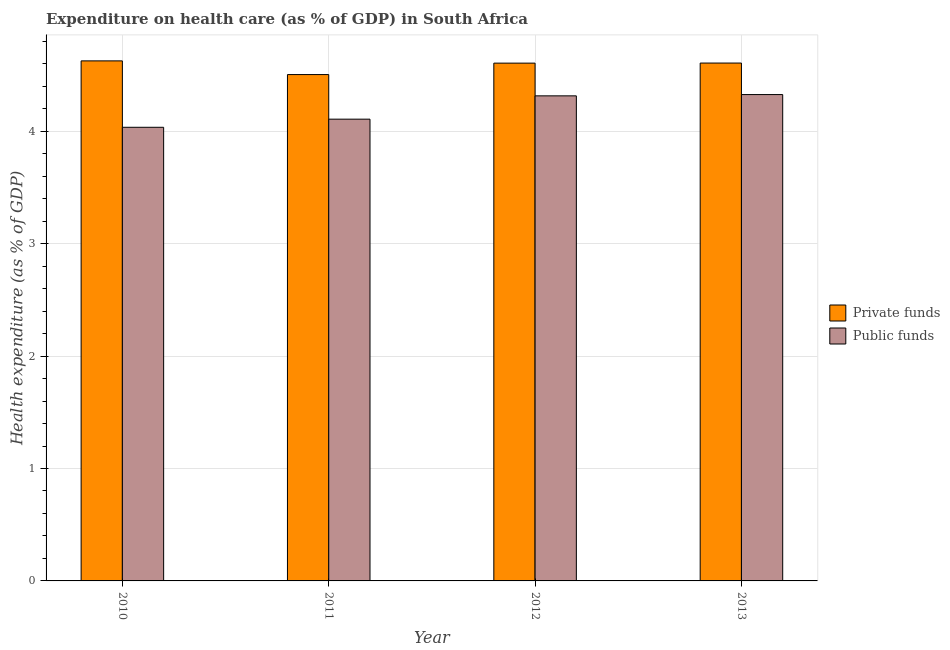How many different coloured bars are there?
Make the answer very short. 2. How many groups of bars are there?
Provide a succinct answer. 4. Are the number of bars per tick equal to the number of legend labels?
Offer a terse response. Yes. How many bars are there on the 4th tick from the left?
Your answer should be very brief. 2. What is the label of the 4th group of bars from the left?
Give a very brief answer. 2013. In how many cases, is the number of bars for a given year not equal to the number of legend labels?
Your answer should be very brief. 0. What is the amount of private funds spent in healthcare in 2011?
Ensure brevity in your answer.  4.5. Across all years, what is the maximum amount of private funds spent in healthcare?
Provide a short and direct response. 4.63. Across all years, what is the minimum amount of private funds spent in healthcare?
Provide a succinct answer. 4.5. In which year was the amount of private funds spent in healthcare maximum?
Offer a terse response. 2010. In which year was the amount of private funds spent in healthcare minimum?
Keep it short and to the point. 2011. What is the total amount of public funds spent in healthcare in the graph?
Your answer should be very brief. 16.78. What is the difference between the amount of private funds spent in healthcare in 2010 and that in 2012?
Your answer should be compact. 0.02. What is the difference between the amount of public funds spent in healthcare in 2013 and the amount of private funds spent in healthcare in 2011?
Your answer should be very brief. 0.22. What is the average amount of public funds spent in healthcare per year?
Your answer should be compact. 4.2. In the year 2011, what is the difference between the amount of private funds spent in healthcare and amount of public funds spent in healthcare?
Offer a very short reply. 0. What is the ratio of the amount of public funds spent in healthcare in 2010 to that in 2012?
Offer a terse response. 0.94. What is the difference between the highest and the second highest amount of public funds spent in healthcare?
Your response must be concise. 0.01. What is the difference between the highest and the lowest amount of private funds spent in healthcare?
Keep it short and to the point. 0.12. What does the 1st bar from the left in 2012 represents?
Your response must be concise. Private funds. What does the 1st bar from the right in 2013 represents?
Provide a succinct answer. Public funds. What is the difference between two consecutive major ticks on the Y-axis?
Offer a very short reply. 1. Are the values on the major ticks of Y-axis written in scientific E-notation?
Offer a terse response. No. Does the graph contain any zero values?
Offer a terse response. No. Does the graph contain grids?
Provide a succinct answer. Yes. Where does the legend appear in the graph?
Offer a very short reply. Center right. How many legend labels are there?
Keep it short and to the point. 2. How are the legend labels stacked?
Provide a succinct answer. Vertical. What is the title of the graph?
Keep it short and to the point. Expenditure on health care (as % of GDP) in South Africa. What is the label or title of the X-axis?
Ensure brevity in your answer.  Year. What is the label or title of the Y-axis?
Your answer should be compact. Health expenditure (as % of GDP). What is the Health expenditure (as % of GDP) in Private funds in 2010?
Provide a succinct answer. 4.63. What is the Health expenditure (as % of GDP) of Public funds in 2010?
Provide a succinct answer. 4.04. What is the Health expenditure (as % of GDP) of Private funds in 2011?
Offer a terse response. 4.5. What is the Health expenditure (as % of GDP) of Public funds in 2011?
Provide a short and direct response. 4.11. What is the Health expenditure (as % of GDP) in Private funds in 2012?
Provide a short and direct response. 4.61. What is the Health expenditure (as % of GDP) in Public funds in 2012?
Provide a short and direct response. 4.31. What is the Health expenditure (as % of GDP) in Private funds in 2013?
Your answer should be compact. 4.61. What is the Health expenditure (as % of GDP) in Public funds in 2013?
Your answer should be very brief. 4.33. Across all years, what is the maximum Health expenditure (as % of GDP) of Private funds?
Ensure brevity in your answer.  4.63. Across all years, what is the maximum Health expenditure (as % of GDP) in Public funds?
Provide a short and direct response. 4.33. Across all years, what is the minimum Health expenditure (as % of GDP) of Private funds?
Your answer should be compact. 4.5. Across all years, what is the minimum Health expenditure (as % of GDP) of Public funds?
Offer a very short reply. 4.04. What is the total Health expenditure (as % of GDP) in Private funds in the graph?
Offer a very short reply. 18.34. What is the total Health expenditure (as % of GDP) in Public funds in the graph?
Your answer should be compact. 16.78. What is the difference between the Health expenditure (as % of GDP) of Private funds in 2010 and that in 2011?
Keep it short and to the point. 0.12. What is the difference between the Health expenditure (as % of GDP) of Public funds in 2010 and that in 2011?
Offer a terse response. -0.07. What is the difference between the Health expenditure (as % of GDP) of Private funds in 2010 and that in 2012?
Make the answer very short. 0.02. What is the difference between the Health expenditure (as % of GDP) of Public funds in 2010 and that in 2012?
Keep it short and to the point. -0.28. What is the difference between the Health expenditure (as % of GDP) in Private funds in 2010 and that in 2013?
Keep it short and to the point. 0.02. What is the difference between the Health expenditure (as % of GDP) in Public funds in 2010 and that in 2013?
Your response must be concise. -0.29. What is the difference between the Health expenditure (as % of GDP) in Private funds in 2011 and that in 2012?
Give a very brief answer. -0.1. What is the difference between the Health expenditure (as % of GDP) of Public funds in 2011 and that in 2012?
Give a very brief answer. -0.21. What is the difference between the Health expenditure (as % of GDP) in Private funds in 2011 and that in 2013?
Your answer should be compact. -0.1. What is the difference between the Health expenditure (as % of GDP) in Public funds in 2011 and that in 2013?
Offer a terse response. -0.22. What is the difference between the Health expenditure (as % of GDP) in Private funds in 2012 and that in 2013?
Keep it short and to the point. -0. What is the difference between the Health expenditure (as % of GDP) in Public funds in 2012 and that in 2013?
Ensure brevity in your answer.  -0.01. What is the difference between the Health expenditure (as % of GDP) in Private funds in 2010 and the Health expenditure (as % of GDP) in Public funds in 2011?
Ensure brevity in your answer.  0.52. What is the difference between the Health expenditure (as % of GDP) in Private funds in 2010 and the Health expenditure (as % of GDP) in Public funds in 2012?
Make the answer very short. 0.31. What is the difference between the Health expenditure (as % of GDP) of Private funds in 2010 and the Health expenditure (as % of GDP) of Public funds in 2013?
Ensure brevity in your answer.  0.3. What is the difference between the Health expenditure (as % of GDP) of Private funds in 2011 and the Health expenditure (as % of GDP) of Public funds in 2012?
Give a very brief answer. 0.19. What is the difference between the Health expenditure (as % of GDP) in Private funds in 2011 and the Health expenditure (as % of GDP) in Public funds in 2013?
Keep it short and to the point. 0.18. What is the difference between the Health expenditure (as % of GDP) in Private funds in 2012 and the Health expenditure (as % of GDP) in Public funds in 2013?
Your response must be concise. 0.28. What is the average Health expenditure (as % of GDP) in Private funds per year?
Offer a terse response. 4.59. What is the average Health expenditure (as % of GDP) of Public funds per year?
Ensure brevity in your answer.  4.2. In the year 2010, what is the difference between the Health expenditure (as % of GDP) in Private funds and Health expenditure (as % of GDP) in Public funds?
Provide a succinct answer. 0.59. In the year 2011, what is the difference between the Health expenditure (as % of GDP) in Private funds and Health expenditure (as % of GDP) in Public funds?
Keep it short and to the point. 0.4. In the year 2012, what is the difference between the Health expenditure (as % of GDP) in Private funds and Health expenditure (as % of GDP) in Public funds?
Offer a terse response. 0.29. In the year 2013, what is the difference between the Health expenditure (as % of GDP) in Private funds and Health expenditure (as % of GDP) in Public funds?
Offer a very short reply. 0.28. What is the ratio of the Health expenditure (as % of GDP) in Public funds in 2010 to that in 2011?
Your answer should be compact. 0.98. What is the ratio of the Health expenditure (as % of GDP) in Private funds in 2010 to that in 2012?
Provide a short and direct response. 1. What is the ratio of the Health expenditure (as % of GDP) of Public funds in 2010 to that in 2012?
Your answer should be compact. 0.94. What is the ratio of the Health expenditure (as % of GDP) of Public funds in 2010 to that in 2013?
Provide a succinct answer. 0.93. What is the ratio of the Health expenditure (as % of GDP) in Private funds in 2011 to that in 2012?
Your answer should be very brief. 0.98. What is the ratio of the Health expenditure (as % of GDP) in Public funds in 2011 to that in 2012?
Your response must be concise. 0.95. What is the ratio of the Health expenditure (as % of GDP) of Private funds in 2011 to that in 2013?
Provide a succinct answer. 0.98. What is the ratio of the Health expenditure (as % of GDP) of Public funds in 2011 to that in 2013?
Offer a terse response. 0.95. What is the ratio of the Health expenditure (as % of GDP) in Private funds in 2012 to that in 2013?
Your response must be concise. 1. What is the ratio of the Health expenditure (as % of GDP) in Public funds in 2012 to that in 2013?
Offer a terse response. 1. What is the difference between the highest and the second highest Health expenditure (as % of GDP) of Private funds?
Offer a very short reply. 0.02. What is the difference between the highest and the second highest Health expenditure (as % of GDP) in Public funds?
Your answer should be compact. 0.01. What is the difference between the highest and the lowest Health expenditure (as % of GDP) of Private funds?
Offer a very short reply. 0.12. What is the difference between the highest and the lowest Health expenditure (as % of GDP) in Public funds?
Give a very brief answer. 0.29. 